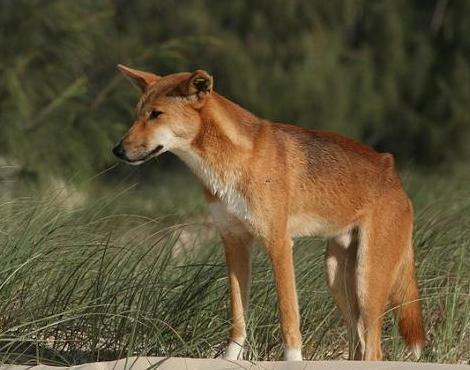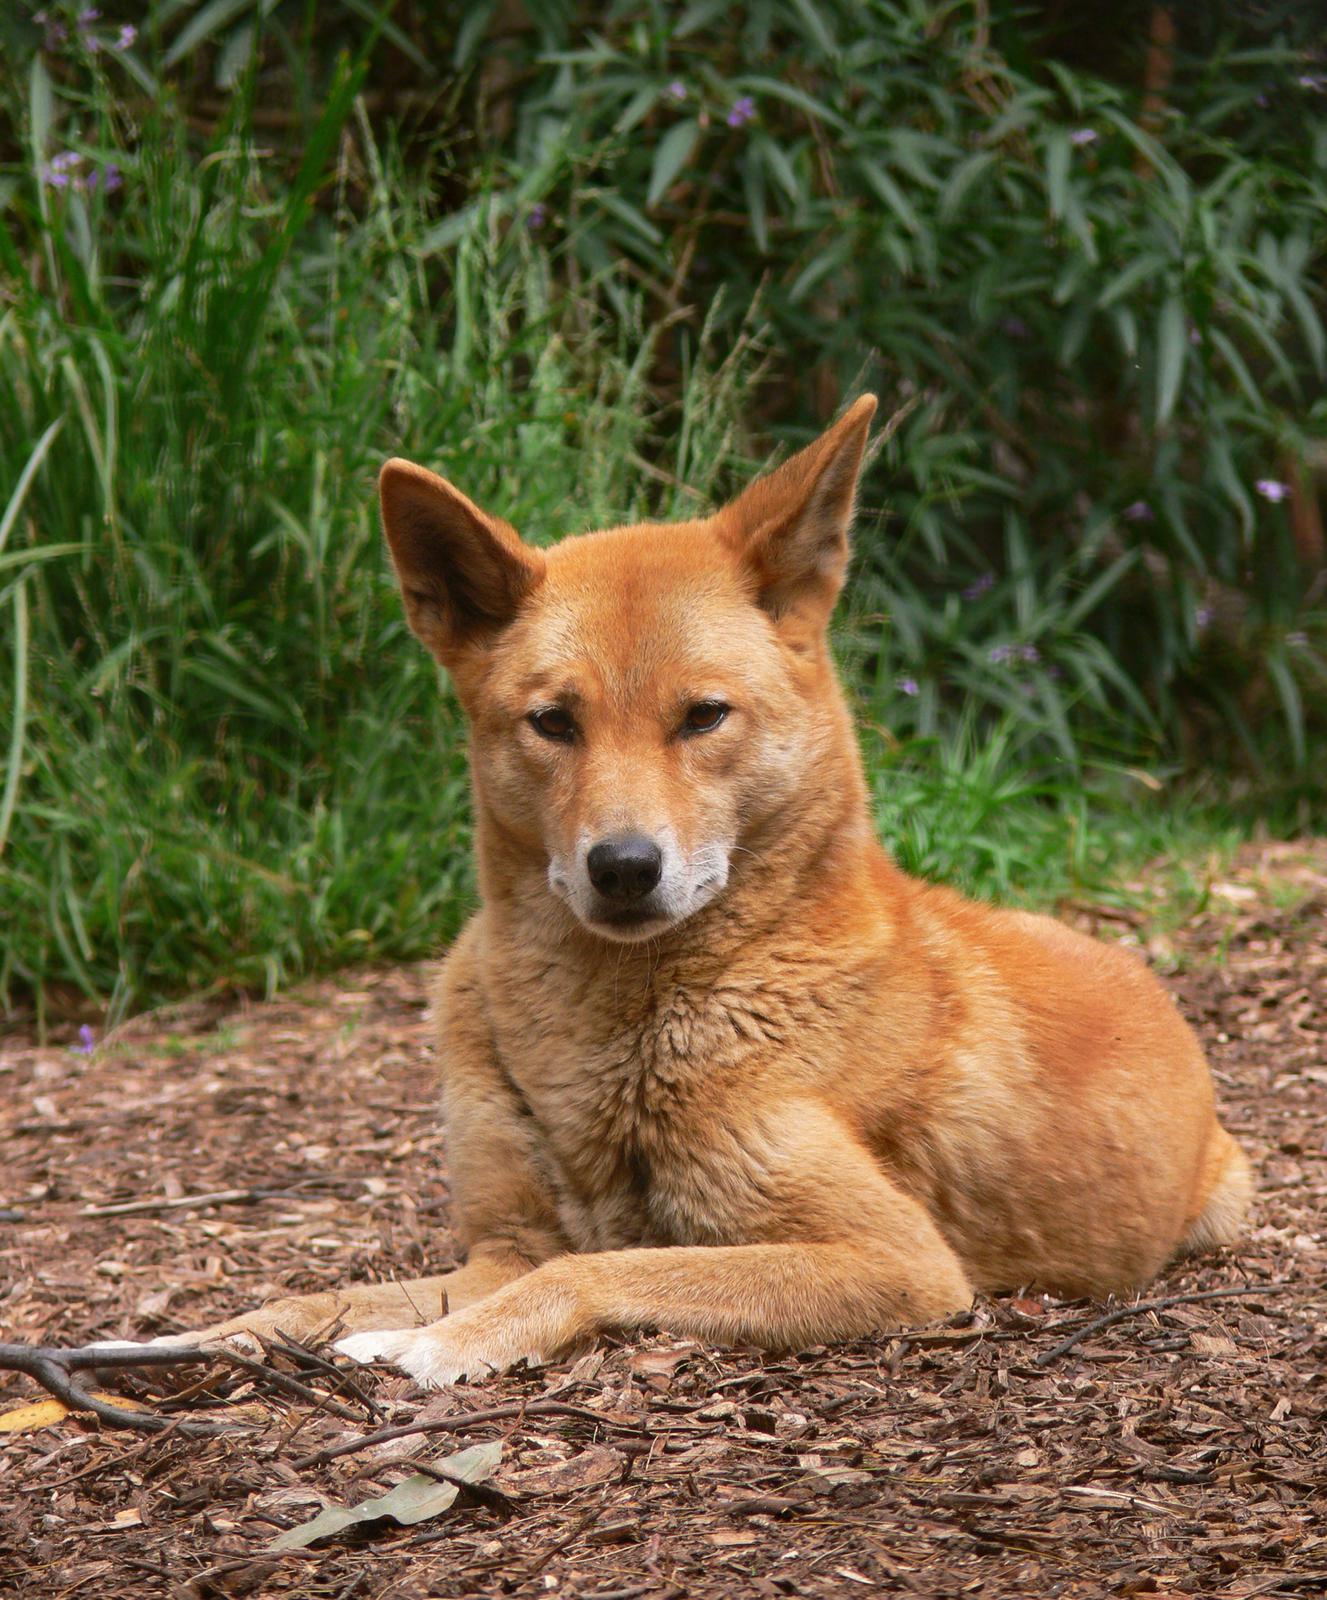The first image is the image on the left, the second image is the image on the right. For the images displayed, is the sentence "One dog is touching another dogs chin with its head." factually correct? Answer yes or no. No. The first image is the image on the left, the second image is the image on the right. For the images displayed, is the sentence "There is at most 2 dingoes." factually correct? Answer yes or no. Yes. 